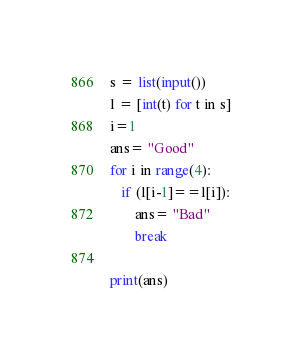<code> <loc_0><loc_0><loc_500><loc_500><_Python_>s = list(input())
l = [int(t) for t in s] 
i=1
ans= "Good"
for i in range(4):
   if (l[i-1]==l[i]):
       ans= "Bad"
       break

print(ans)</code> 